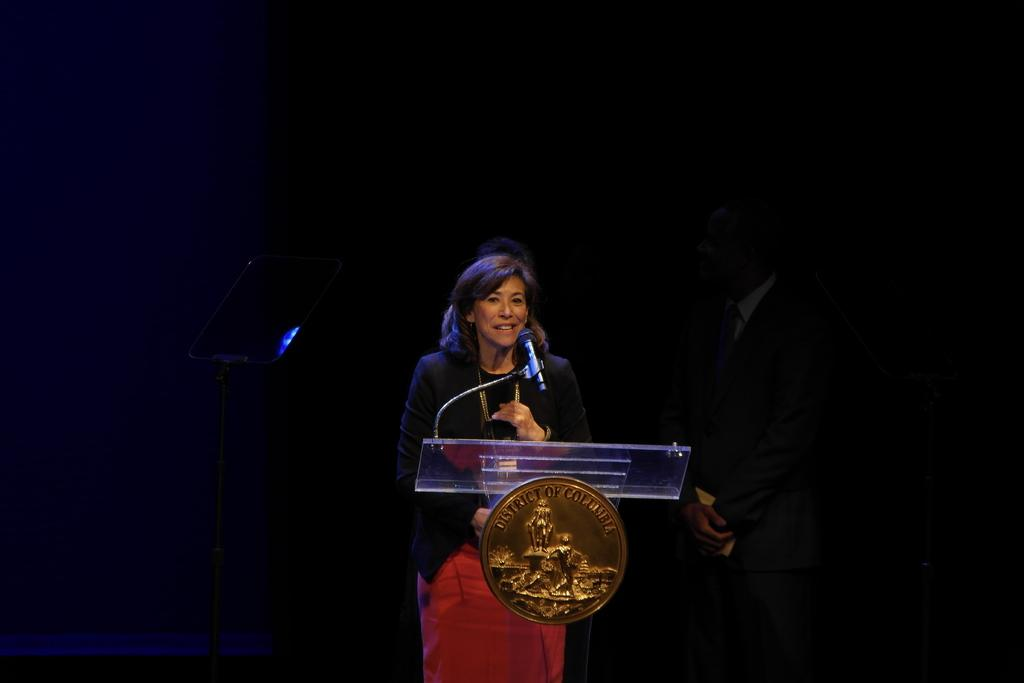Who is the main subject in the image? There is a woman in the image. Where is the woman positioned in the image? The woman is standing in the middle of the image. What is the woman holding in the image? The woman is holding a microphone. What can be seen at the bottom of the image? There is an object at the bottom of the image. What type of muscle can be seen flexing in the image? There is no muscle visible in the image, as it features a woman holding a microphone and standing in the middle of the image. 